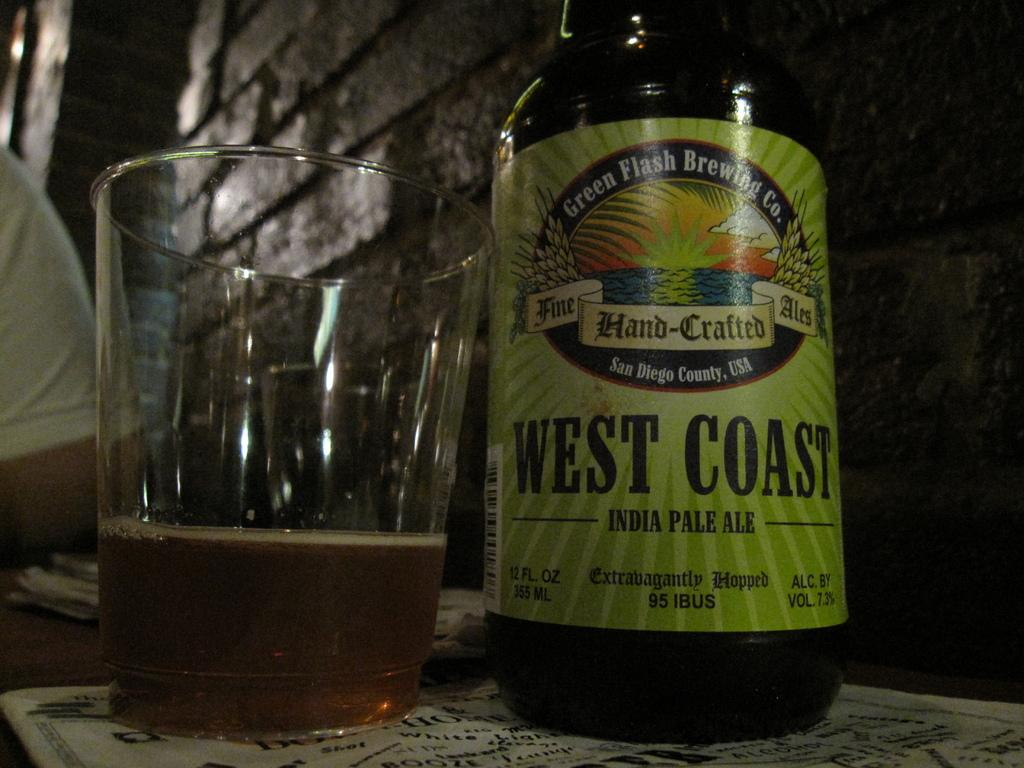<image>
Summarize the visual content of the image. a bottle of beer with west coast on it 